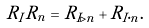<formula> <loc_0><loc_0><loc_500><loc_500>R _ { I } R _ { n } = R _ { I \triangleright n } + R _ { I \cdot n } .</formula> 